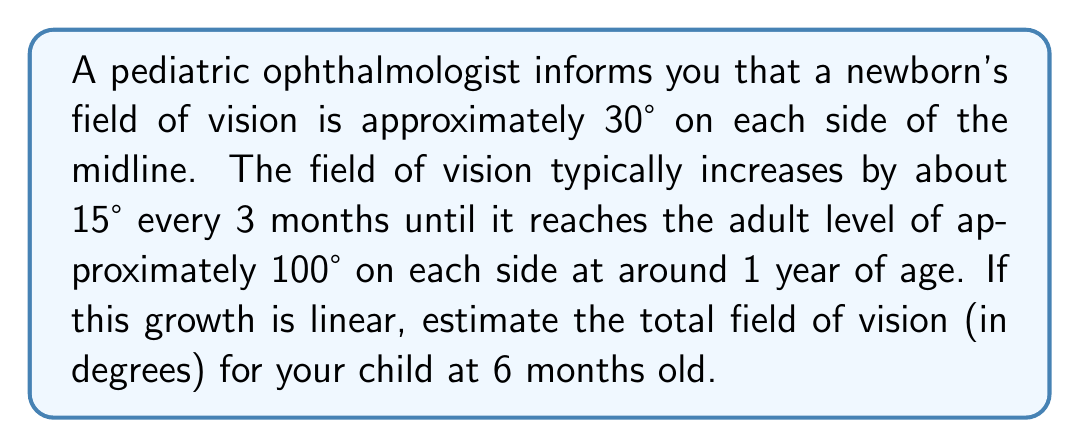Can you solve this math problem? Let's approach this step-by-step:

1) First, let's define our variables:
   $\theta_0$ = initial field of vision (at birth)
   $\theta_f$ = final field of vision (at 1 year)
   $r$ = rate of increase per month

2) We're given:
   $\theta_0 = 30°$ on each side
   $\theta_f = 100°$ on each side
   Rate of increase = $15°$ every 3 months

3) Calculate the rate of increase per month:
   $r = \frac{15°}{3 \text{ months}} = 5°$ per month

4) The total increase over 12 months:
   $\theta_f - \theta_0 = 100° - 30° = 70°$

5) We can verify that this matches our rate:
   $70° = 5°/\text{month} \times 12 \text{ months}$

6) For a 6-month-old child, the increase would be:
   $\text{Increase} = 5°/\text{month} \times 6 \text{ months} = 30°$

7) So at 6 months, the field of vision on each side would be:
   $\theta_6 = \theta_0 + 30° = 30° + 30° = 60°$

8) Remember, this is on each side. For total field of vision, we double this:
   $\text{Total field of vision} = 2 \times 60° = 120°$

[asy]
size(200);
draw((-100,0)--(100,0));
draw((0,-50)--(0,50));
draw(arc((0,0),90,150,30),Arrow);
draw(arc((0,0),90,30,330),Arrow);
label("120°",(0,40));
[/asy]
Answer: The estimated total field of vision for a 6-month-old child is $120°$. 